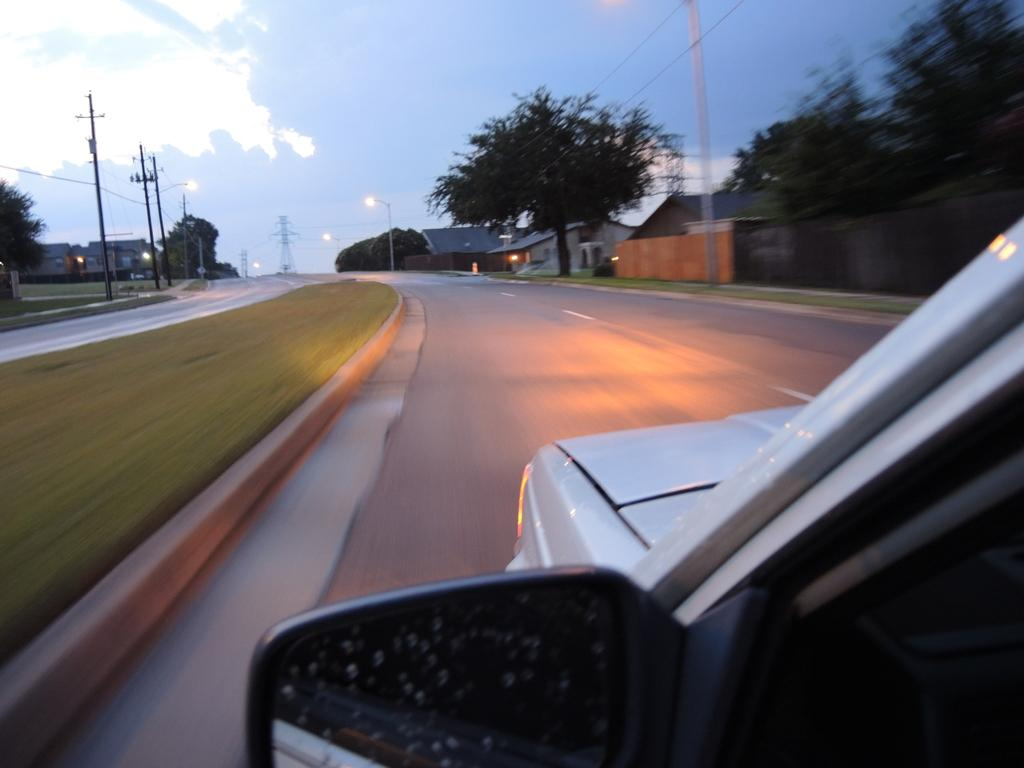What is the main subject of the image? There is a vehicle on the road in the image. What can be seen in the background of the image? The sky with clouds is visible in the background of the image. What type of vegetation is present in the image? There is grass in the image. What structures are visible in the image? There are houses, poles, and trees in the image. How many legs can be seen on the flock of animals in the image? There are no animals or legs visible in the image. What type of group is gathered around the vehicle in the image? There is no group of people or animals gathered around the vehicle in the image. 